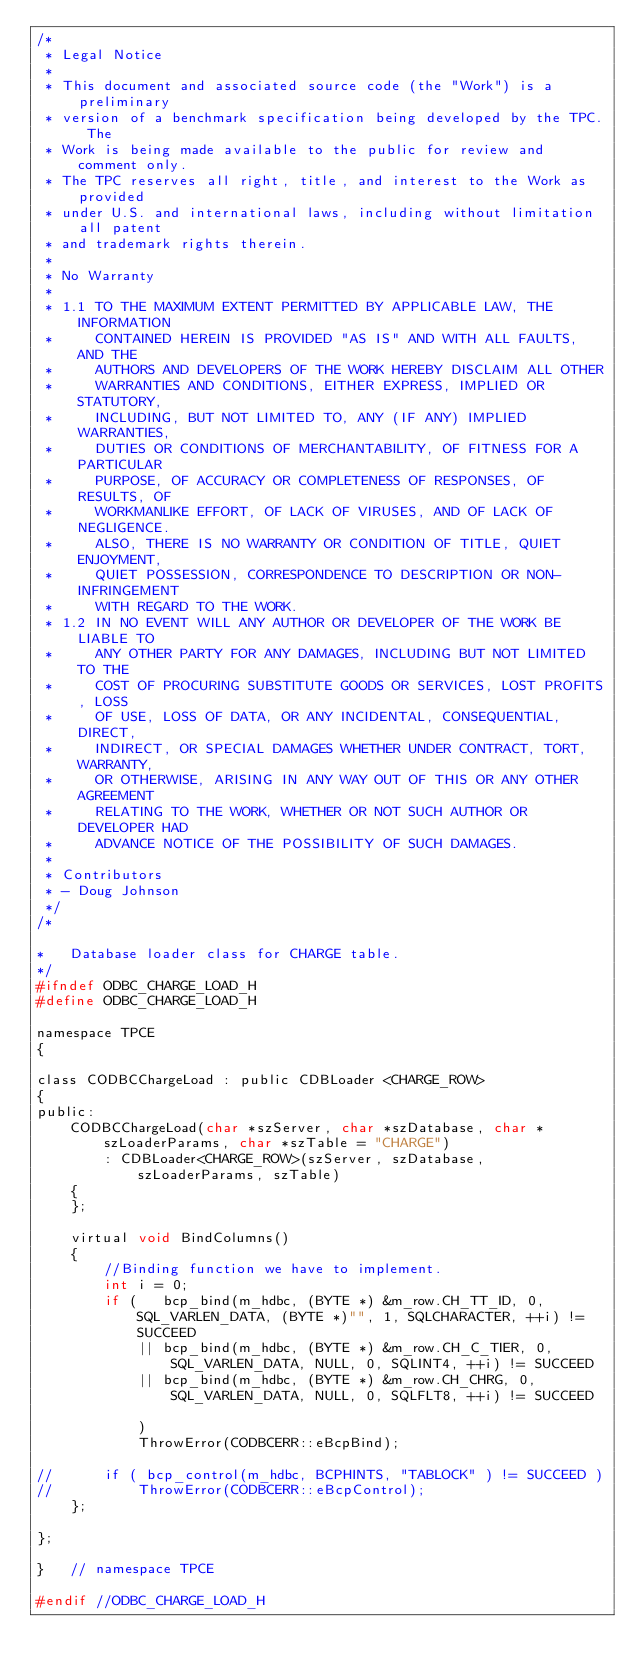<code> <loc_0><loc_0><loc_500><loc_500><_C_>/*
 * Legal Notice
 *
 * This document and associated source code (the "Work") is a preliminary
 * version of a benchmark specification being developed by the TPC. The
 * Work is being made available to the public for review and comment only.
 * The TPC reserves all right, title, and interest to the Work as provided
 * under U.S. and international laws, including without limitation all patent
 * and trademark rights therein.
 *
 * No Warranty
 *
 * 1.1 TO THE MAXIMUM EXTENT PERMITTED BY APPLICABLE LAW, THE INFORMATION
 *     CONTAINED HEREIN IS PROVIDED "AS IS" AND WITH ALL FAULTS, AND THE
 *     AUTHORS AND DEVELOPERS OF THE WORK HEREBY DISCLAIM ALL OTHER
 *     WARRANTIES AND CONDITIONS, EITHER EXPRESS, IMPLIED OR STATUTORY,
 *     INCLUDING, BUT NOT LIMITED TO, ANY (IF ANY) IMPLIED WARRANTIES,
 *     DUTIES OR CONDITIONS OF MERCHANTABILITY, OF FITNESS FOR A PARTICULAR
 *     PURPOSE, OF ACCURACY OR COMPLETENESS OF RESPONSES, OF RESULTS, OF
 *     WORKMANLIKE EFFORT, OF LACK OF VIRUSES, AND OF LACK OF NEGLIGENCE.
 *     ALSO, THERE IS NO WARRANTY OR CONDITION OF TITLE, QUIET ENJOYMENT,
 *     QUIET POSSESSION, CORRESPONDENCE TO DESCRIPTION OR NON-INFRINGEMENT
 *     WITH REGARD TO THE WORK.
 * 1.2 IN NO EVENT WILL ANY AUTHOR OR DEVELOPER OF THE WORK BE LIABLE TO
 *     ANY OTHER PARTY FOR ANY DAMAGES, INCLUDING BUT NOT LIMITED TO THE
 *     COST OF PROCURING SUBSTITUTE GOODS OR SERVICES, LOST PROFITS, LOSS
 *     OF USE, LOSS OF DATA, OR ANY INCIDENTAL, CONSEQUENTIAL, DIRECT,
 *     INDIRECT, OR SPECIAL DAMAGES WHETHER UNDER CONTRACT, TORT, WARRANTY,
 *     OR OTHERWISE, ARISING IN ANY WAY OUT OF THIS OR ANY OTHER AGREEMENT
 *     RELATING TO THE WORK, WHETHER OR NOT SUCH AUTHOR OR DEVELOPER HAD
 *     ADVANCE NOTICE OF THE POSSIBILITY OF SUCH DAMAGES.
 *
 * Contributors
 * - Doug Johnson
 */
/*

*   Database loader class for CHARGE table.
*/
#ifndef ODBC_CHARGE_LOAD_H
#define ODBC_CHARGE_LOAD_H

namespace TPCE
{

class CODBCChargeLoad : public CDBLoader <CHARGE_ROW>
{
public:
    CODBCChargeLoad(char *szServer, char *szDatabase, char *szLoaderParams, char *szTable = "CHARGE")
        : CDBLoader<CHARGE_ROW>(szServer, szDatabase, szLoaderParams, szTable)
    {
    };

    virtual void BindColumns()
    {
        //Binding function we have to implement.
        int i = 0;
        if (   bcp_bind(m_hdbc, (BYTE *) &m_row.CH_TT_ID, 0, SQL_VARLEN_DATA, (BYTE *)"", 1, SQLCHARACTER, ++i) != SUCCEED
            || bcp_bind(m_hdbc, (BYTE *) &m_row.CH_C_TIER, 0, SQL_VARLEN_DATA, NULL, 0, SQLINT4, ++i) != SUCCEED
            || bcp_bind(m_hdbc, (BYTE *) &m_row.CH_CHRG, 0, SQL_VARLEN_DATA, NULL, 0, SQLFLT8, ++i) != SUCCEED

            )
            ThrowError(CODBCERR::eBcpBind);

//      if ( bcp_control(m_hdbc, BCPHINTS, "TABLOCK" ) != SUCCEED )
//          ThrowError(CODBCERR::eBcpControl);
    };

};

}   // namespace TPCE

#endif //ODBC_CHARGE_LOAD_H
</code> 